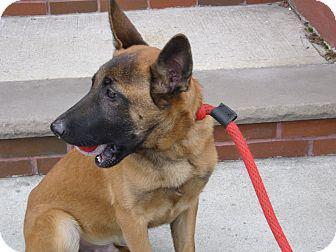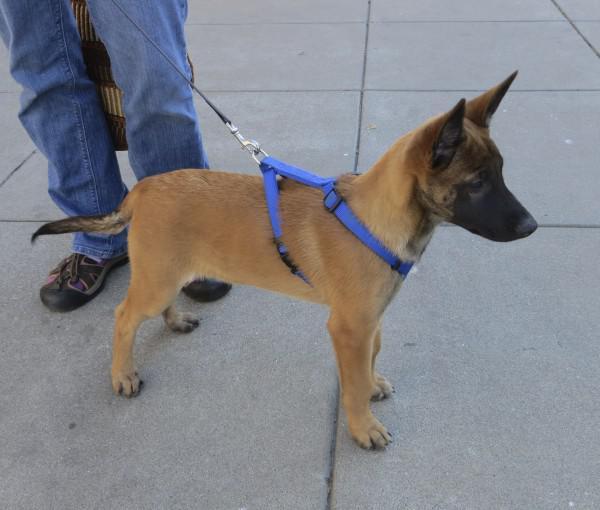The first image is the image on the left, the second image is the image on the right. Analyze the images presented: Is the assertion "The dog in the image on the left is on a leash." valid? Answer yes or no. Yes. The first image is the image on the left, the second image is the image on the right. For the images shown, is this caption "One image shows a standing dog wearing a leash, and the other shows a dog sitting upright." true? Answer yes or no. Yes. 